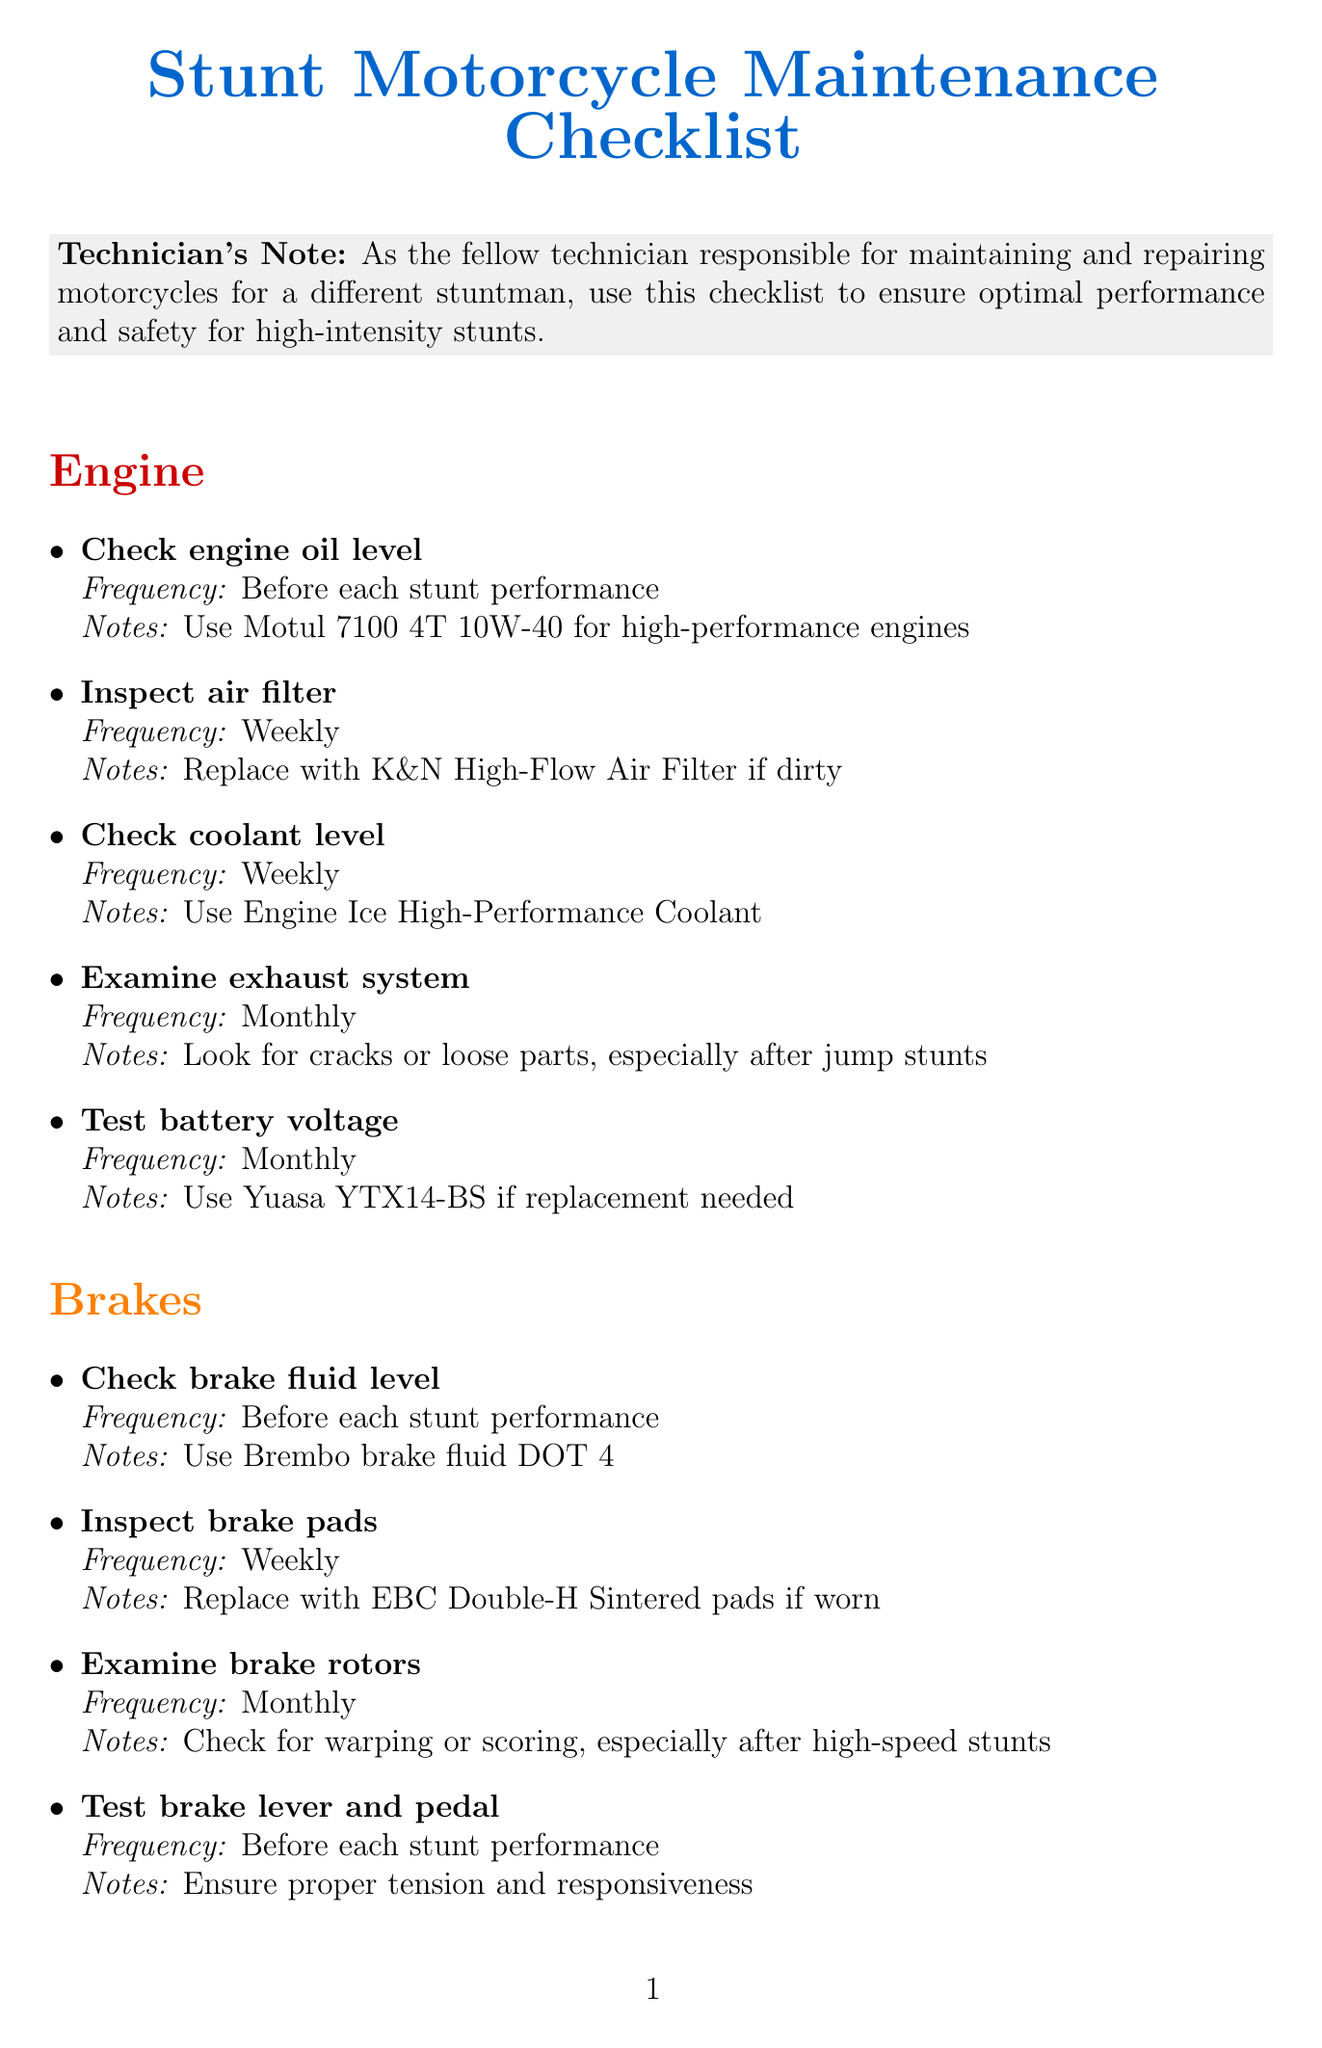What is the recommended engine oil? The document specifies using Motul 7100 4T 10W-40 for high-performance engines.
Answer: Motul 7100 4T 10W-40 How often should brake pads be inspected? The document states brake pads should be inspected weekly.
Answer: Weekly What should be checked before each stunt performance? The document lists multiple tasks including engine oil level, brake fluid level, tire pressure, and chain tension.
Answer: Engine oil level What must be used for coolant according to the checklist? The document recommends Engine Ice High-Performance Coolant for coolant.
Answer: Engine Ice High-Performance Coolant How frequently should the stunt cage be inspected? The document specifies inspecting the stunt cage on a monthly basis.
Answer: Monthly Which tire brand should be used if tire tread is worn? The document recommends replacing with Michelin Power RS if the tire tread is worn.
Answer: Michelin Power RS What is the purpose of testing the kill switch? The document notes that testing the kill switch ensures proper functioning for emergency situations.
Answer: Emergency situations What color is used for the Engine section in the document? The document specifies the color red for the Engine section.
Answer: Red When should the sprocket condition be checked? The checklist indicates that the sprocket condition should be checked weekly.
Answer: Weekly 